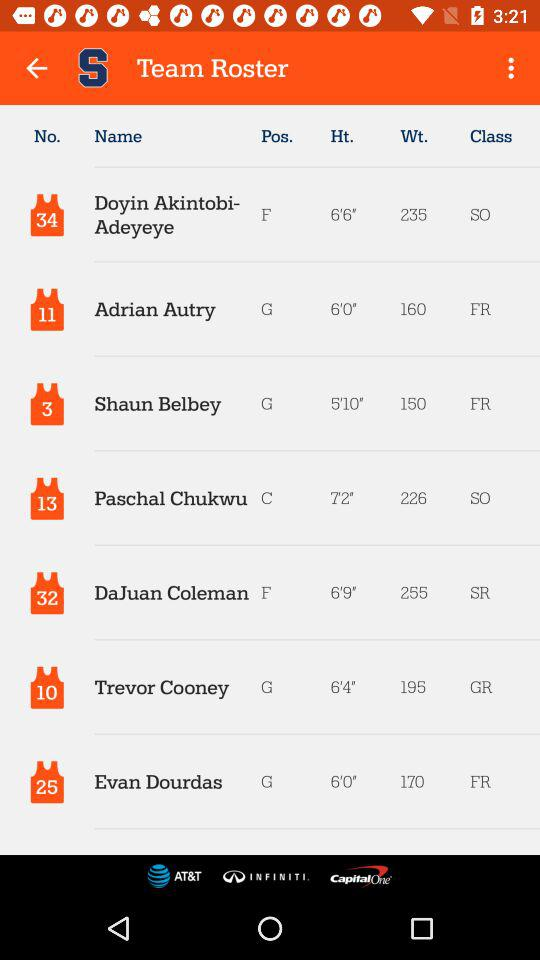What's the jersey number of "Adrian Autry"? The jersey number of "Adrian Autry" is 11. 